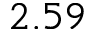<formula> <loc_0><loc_0><loc_500><loc_500>2 . 5 9</formula> 